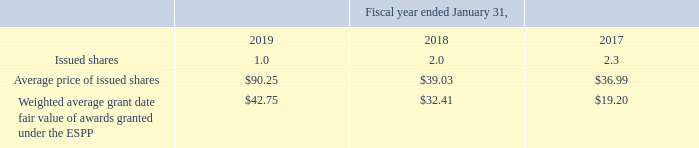1998 Employee Qualified Stock Purchase Plan (“ESPP”)
Under Autodesk’s ESPP, which was approved by stockholders in 1998, eligible employees may purchase shares of Autodesk’s common stock at their discretion using up to 15% of their eligible compensation, subject to certain limitations, at 85% of the lower of Autodesk's closing price (fair market value) on the offering date or the exercise date. The offering period for ESPP awards consists of four, six-month exercise periods within a 24-month offering period.
At January 31, 2019, a total of 8.1 million shares were available for future issuance. Under the ESPP, the Company issues shares on the first trading day following March 31 and September 30 of each fiscal year. The ESPP does not have an expiration date.
A summary of the ESPP activity for the fiscal years ended January 31, 2019, 2018 and 2017 is as follows:
Autodesk recorded $27.2 million, $25.7 million, and $25.9 million of compensation expense associated with the ESPP in fiscal 2019, 2018, and 2017, respectively.
At January 31, 2019, how many shares were available for future issuance? 8.1 million. What is the offering period for ESPP awards? The offering period for espp awards consists of four, six-month exercise periods within a 24-month offering period. What was the average price of issued shares in the fiscal year ended 2018? $39.03. What was the average compensation expense over the period from 2017 to 2019?
Answer scale should be: million. (27.2+25.7+25.9)/3
Answer: 26.27. What is the change in the weighted average grant date fair value of awards granted under the ESPP from 2017 to 2018? 32.41-19.2
Answer: 13.21. What was the average compensation expense over the period from 2017 to 2019? (27.2+25.7+25.9)/3 
Answer: 26.27. 